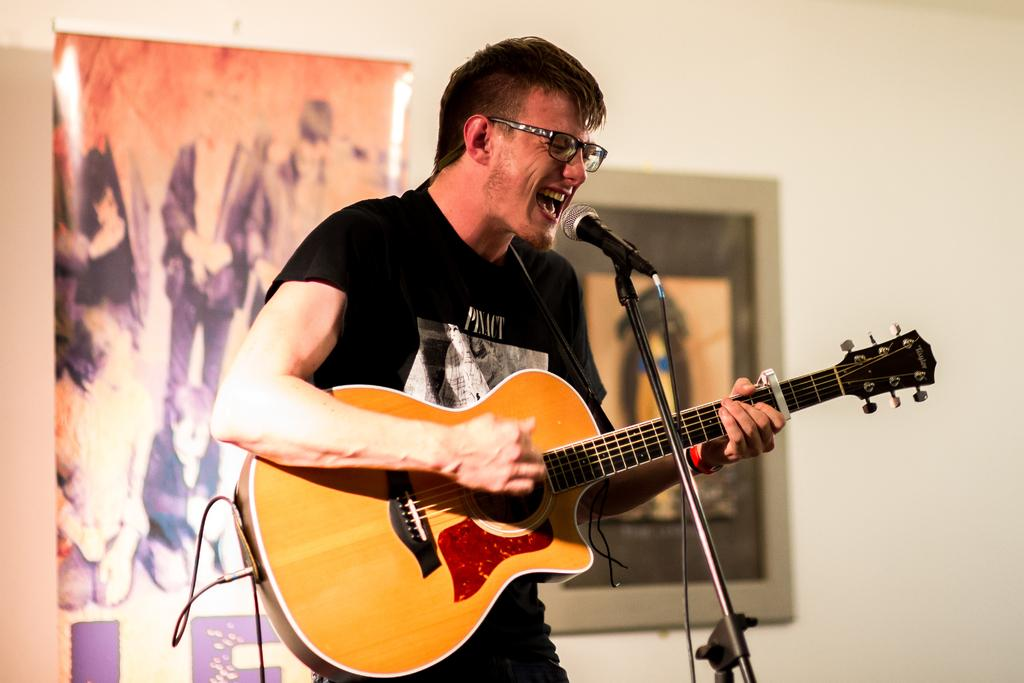What is the man in the image doing? The man is playing the guitar and singing on a microphone. What object is the man holding in the image? The man is holding a guitar. What can be seen on the wall in the background of the image? There are frames and posters on the wall in the background. What type of loaf is the man using as a prop while singing in the image? There is no loaf present in the image; the man is holding a guitar and singing on a microphone. 